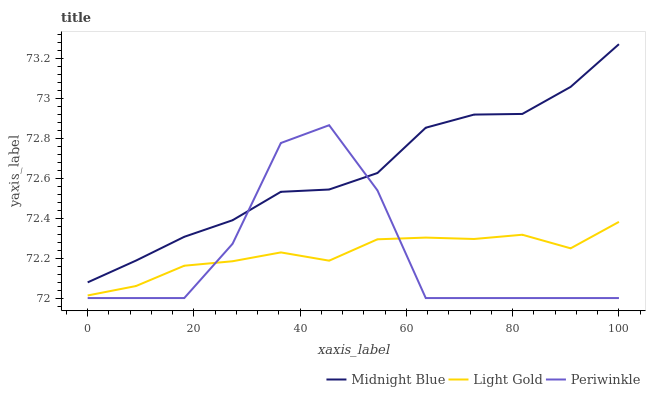Does Periwinkle have the minimum area under the curve?
Answer yes or no. Yes. Does Midnight Blue have the maximum area under the curve?
Answer yes or no. Yes. Does Light Gold have the minimum area under the curve?
Answer yes or no. No. Does Light Gold have the maximum area under the curve?
Answer yes or no. No. Is Light Gold the smoothest?
Answer yes or no. Yes. Is Periwinkle the roughest?
Answer yes or no. Yes. Is Midnight Blue the smoothest?
Answer yes or no. No. Is Midnight Blue the roughest?
Answer yes or no. No. Does Periwinkle have the lowest value?
Answer yes or no. Yes. Does Light Gold have the lowest value?
Answer yes or no. No. Does Midnight Blue have the highest value?
Answer yes or no. Yes. Does Light Gold have the highest value?
Answer yes or no. No. Is Light Gold less than Midnight Blue?
Answer yes or no. Yes. Is Midnight Blue greater than Light Gold?
Answer yes or no. Yes. Does Light Gold intersect Periwinkle?
Answer yes or no. Yes. Is Light Gold less than Periwinkle?
Answer yes or no. No. Is Light Gold greater than Periwinkle?
Answer yes or no. No. Does Light Gold intersect Midnight Blue?
Answer yes or no. No. 